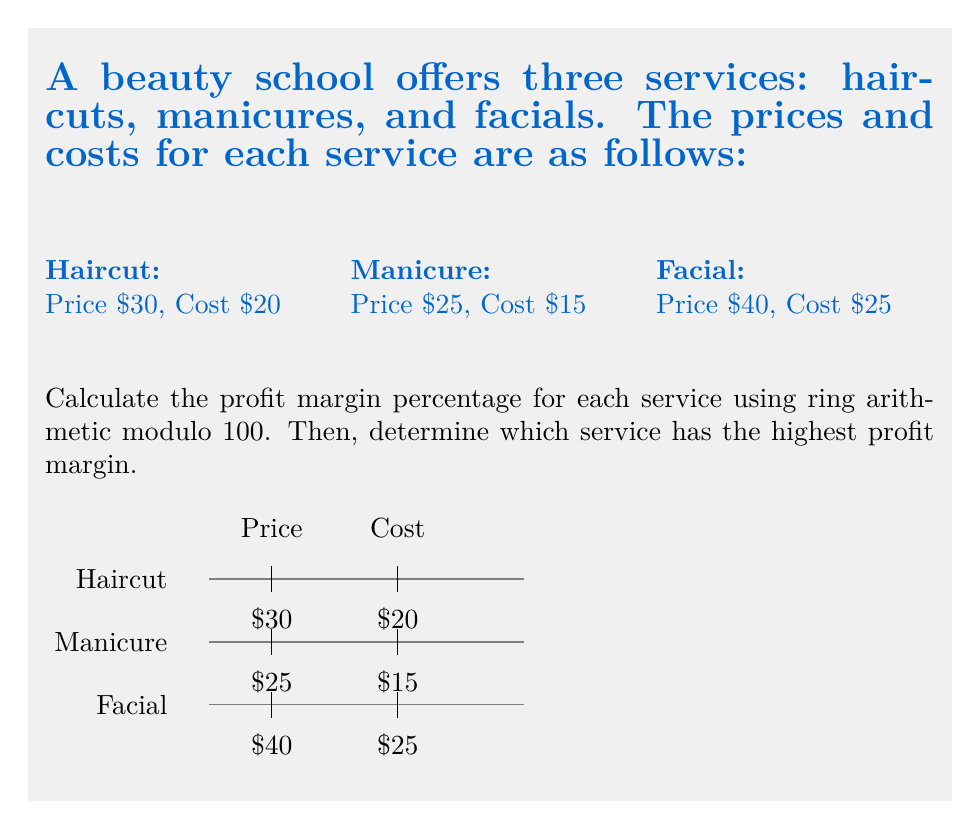Provide a solution to this math problem. Let's calculate the profit margin percentage for each service using ring arithmetic modulo 100:

1. Haircut:
   Profit = Price - Cost = $30 - $20 = $10
   Profit Margin = (Profit / Price) * 100%
   $$(10 / 30) * 100 \equiv 33.33... \equiv 33 \pmod{100}$$

2. Manicure:
   Profit = Price - Cost = $25 - $15 = $10
   Profit Margin = (Profit / Price) * 100%
   $$(10 / 25) * 100 \equiv 40 \pmod{100}$$

3. Facial:
   Profit = Price - Cost = $40 - $25 = $15
   Profit Margin = (Profit / Price) * 100%
   $$(15 / 40) * 100 \equiv 37.5 \equiv 38 \pmod{100}$$

In ring arithmetic modulo 100, we only consider the remainder when divided by 100. This effectively gives us the percentage without the decimal places.

Comparing the profit margins:
Haircut: 33%
Manicure: 40%
Facial: 38%

The service with the highest profit margin is the manicure at 40%.
Answer: Manicure: 40% 